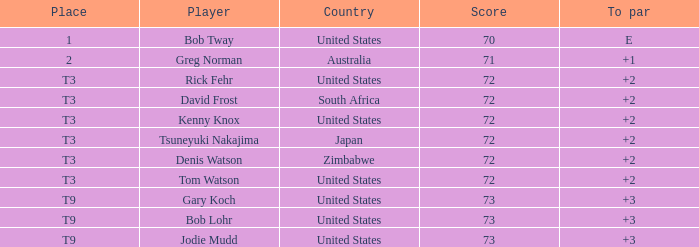What is the low score for TO par +2 in japan? 72.0. 